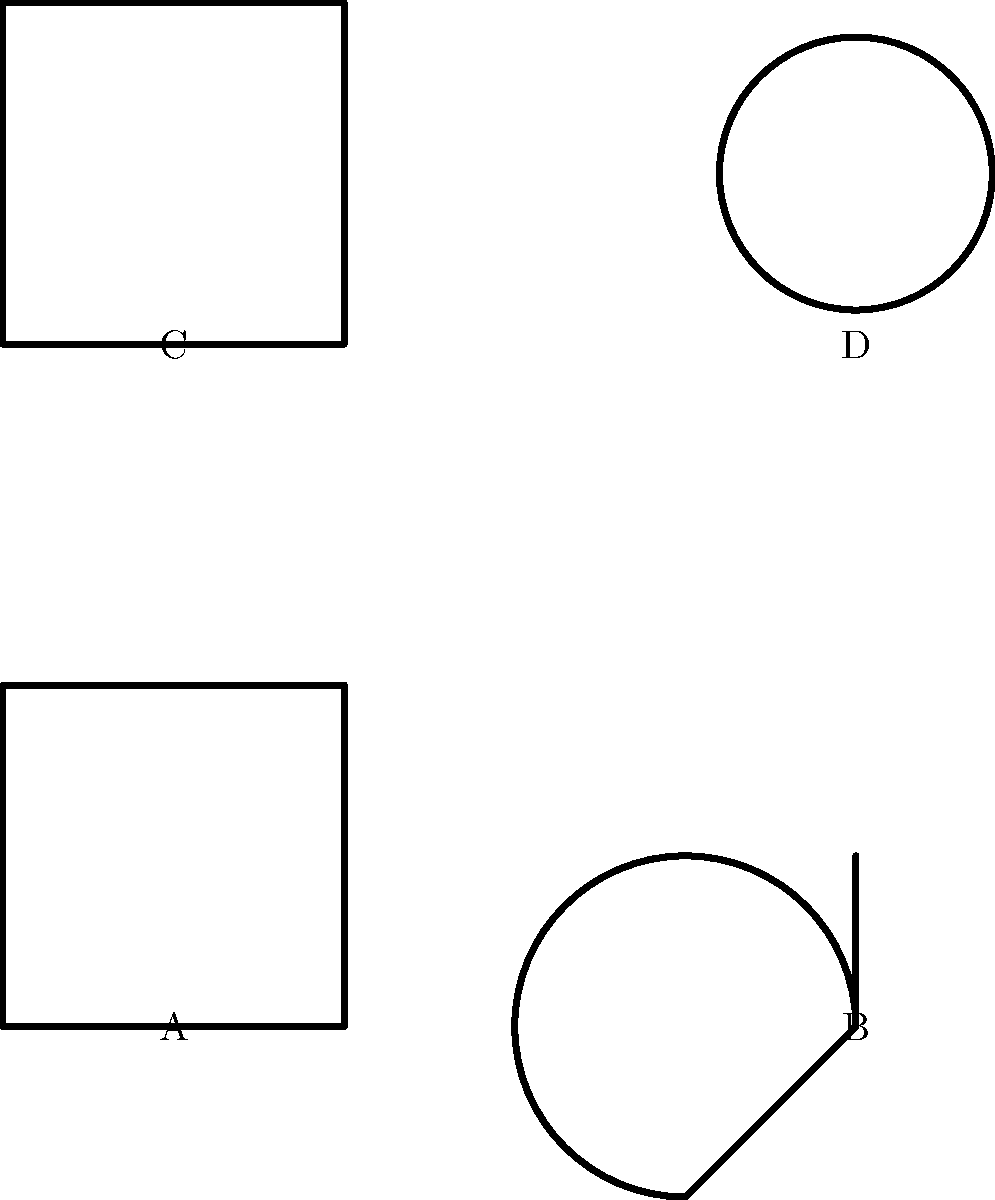Which of the symbols shown above represents the Ghanaian Adinkra concept of "returning to the past to build for the future"? To answer this question, we need to analyze each symbol and its cultural significance:

1. Symbol A: This is an Adinkra symbol, but it's a basic square shape that doesn't specifically represent the concept described in the question.

2. Symbol B: This is the Sankofa symbol, which is indeed an Adinkra symbol from Ghana. The Sankofa is depicted as a bird with its head turned backwards, often stylized as shown in the image. In Akan (Ghanaian) culture, Sankofa symbolizes the importance of learning from the past to build a prosperous future. The literal translation of Sankofa is "go back and get it" (san - to return; ko - to go; fa - to fetch, to seek and take).

3. Symbol C: This appears to be a simplified representation of Kente cloth, a traditional Ghanaian textile. While significant in Ghanaian culture, it doesn't specifically represent the concept mentioned in the question.

4. Symbol D: This circular symbol might represent an African mask, but it doesn't directly relate to the concept of returning to the past for future growth.

Given the description in the question, Symbol B (the Sankofa) is the correct answer as it directly represents the Ghanaian Adinkra concept of "returning to the past to build for the future."
Answer: B 